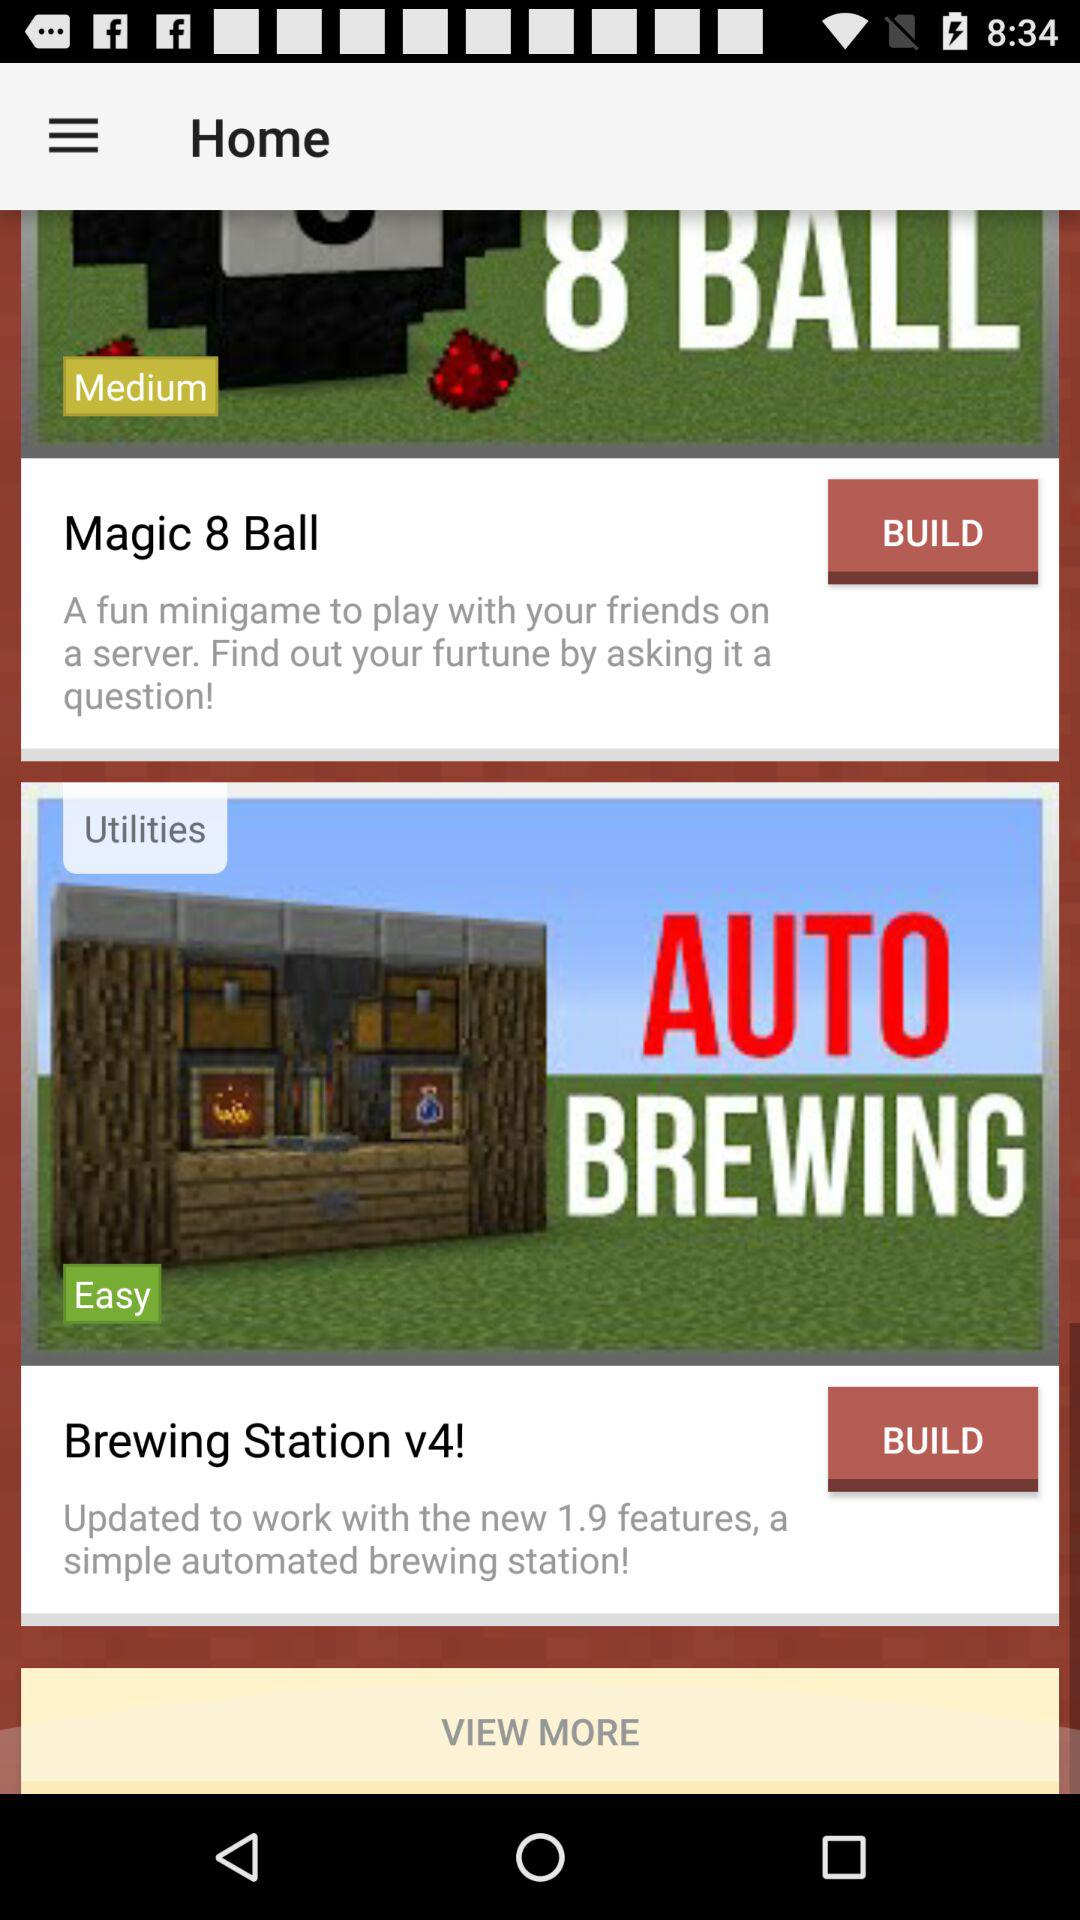How many magic balls are there? There are 8 magic balls. 